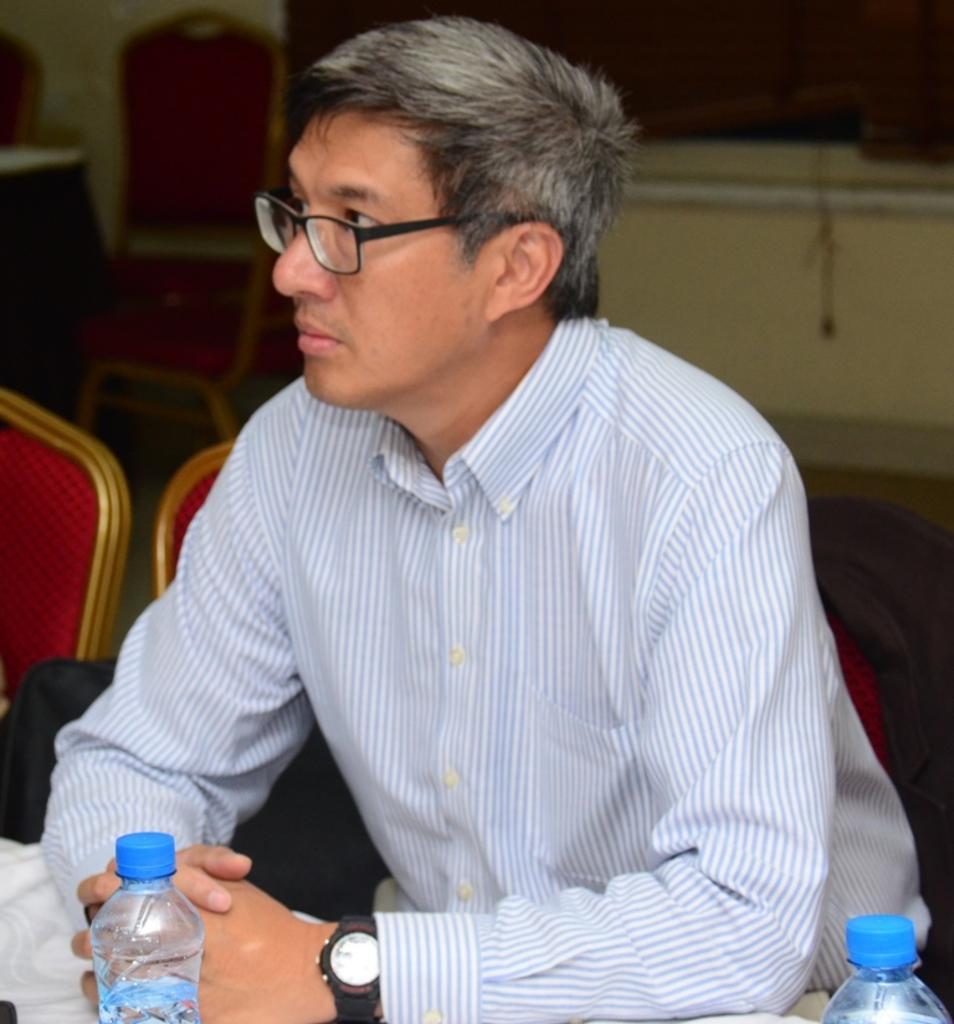Describe this image in one or two sentences. Here we can see that a person is sitting on the chair and looking, and in front there is the table and water bottle on it. 